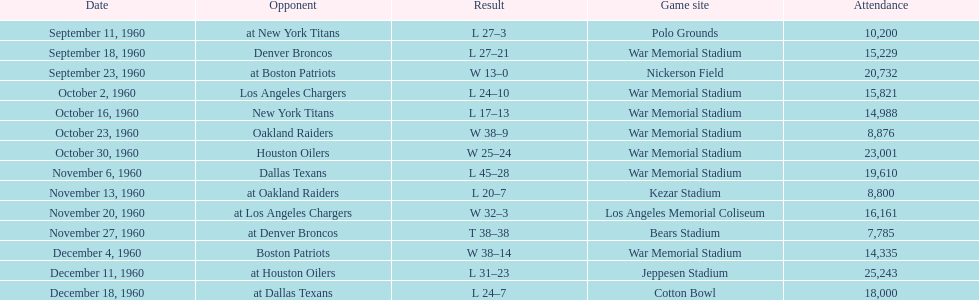In a single game, what was the biggest point difference? 29. 